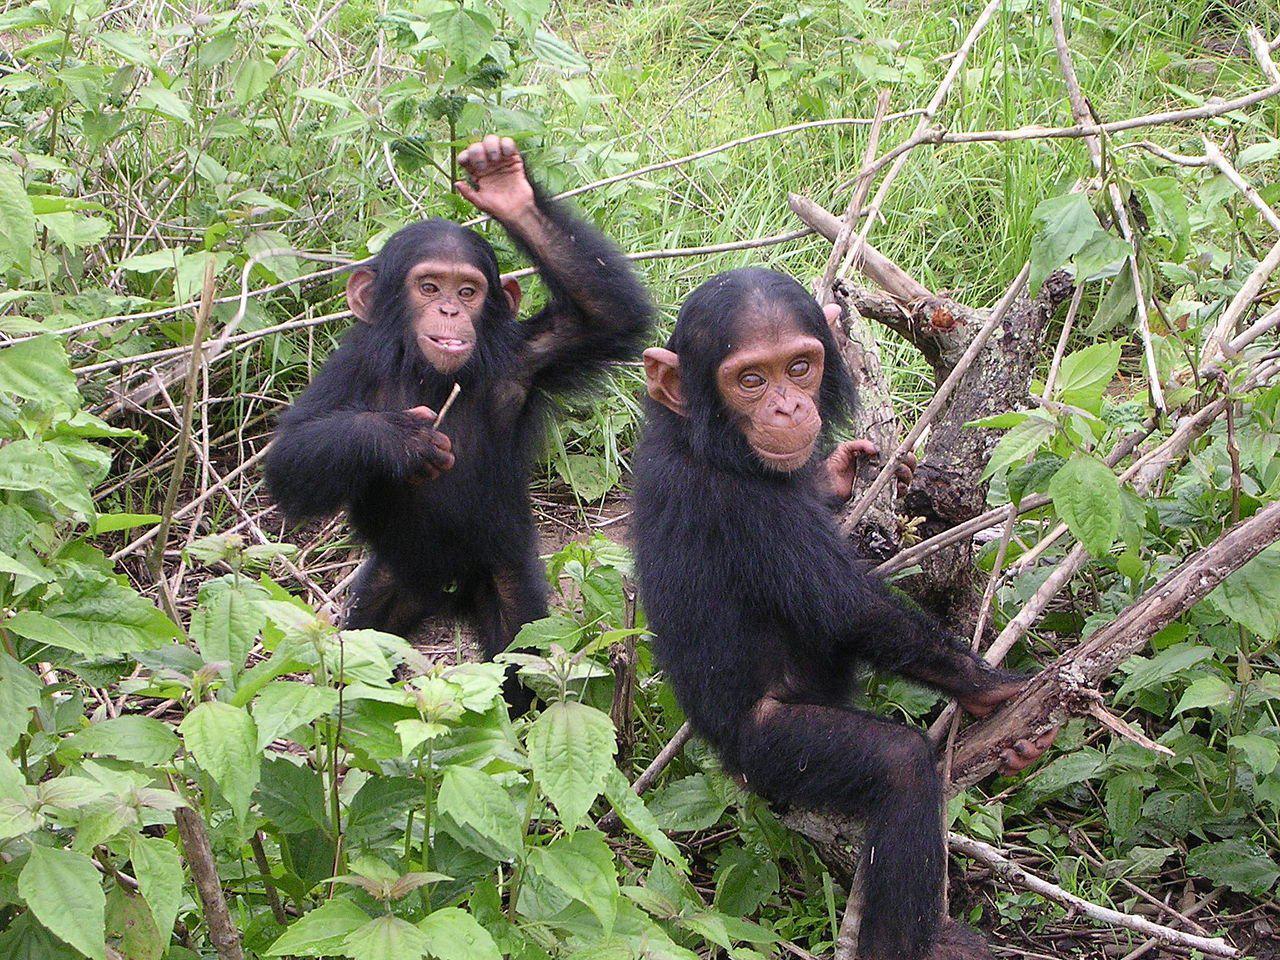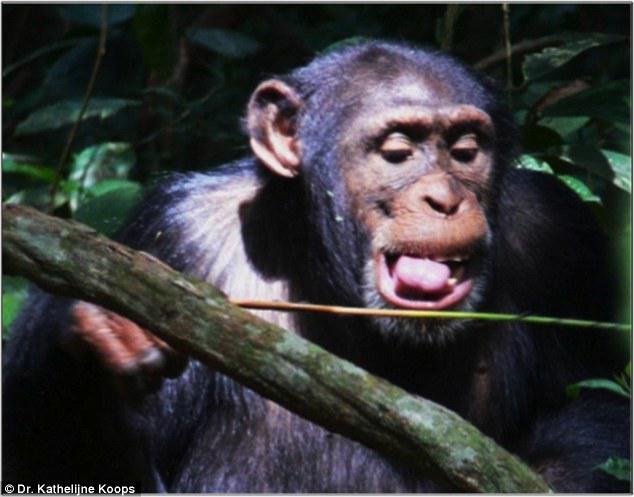The first image is the image on the left, the second image is the image on the right. For the images shown, is this caption "There are more animals in the image on the left." true? Answer yes or no. Yes. The first image is the image on the left, the second image is the image on the right. Considering the images on both sides, is "One image shows a close-mouthed chimp holding a stick and poking it down at something." valid? Answer yes or no. No. 